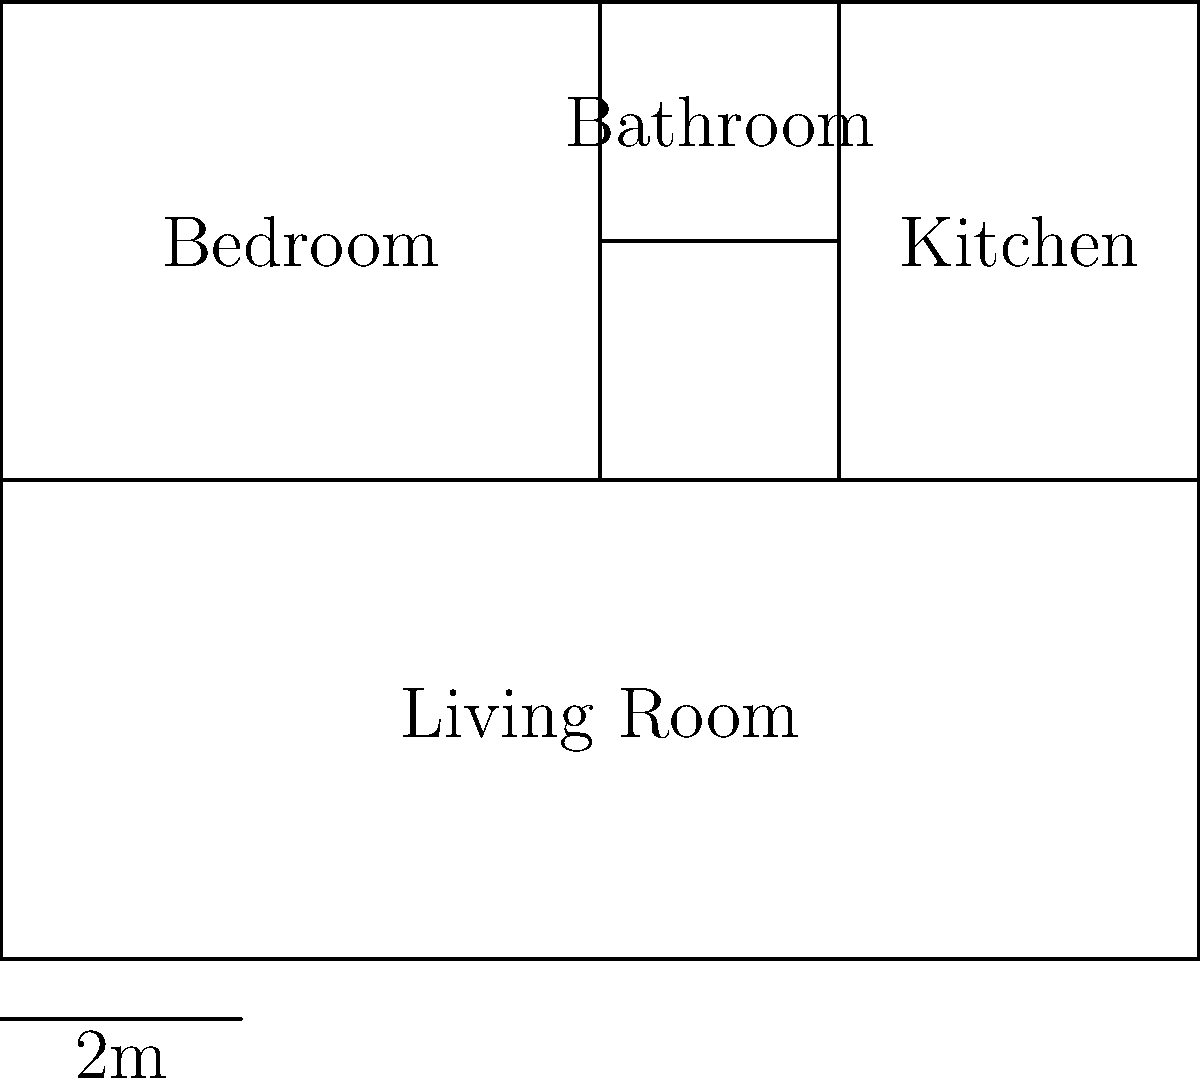Based on the floor plan layout of this small apartment, which room has direct access to all other rooms? To determine which room has direct access to all other rooms, we need to analyze the connections between each room:

1. Bedroom: 
   - Connected to the Living Room
   - Not directly connected to the Bathroom or Kitchen

2. Bathroom:
   - Connected to the Kitchen
   - Not directly connected to the Bedroom or Living Room

3. Kitchen:
   - Connected to the Bathroom
   - Connected to the Living Room
   - Not directly connected to the Bedroom

4. Living Room:
   - Connected to the Bedroom
   - Connected to the Kitchen
   - Indirectly connected to the Bathroom through the Kitchen

By analyzing these connections, we can see that the Living Room is the only space that has either direct or indirect access to all other rooms in the apartment. It serves as a central hub, connecting the Bedroom and Kitchen, and providing indirect access to the Bathroom through the Kitchen.
Answer: Living Room 